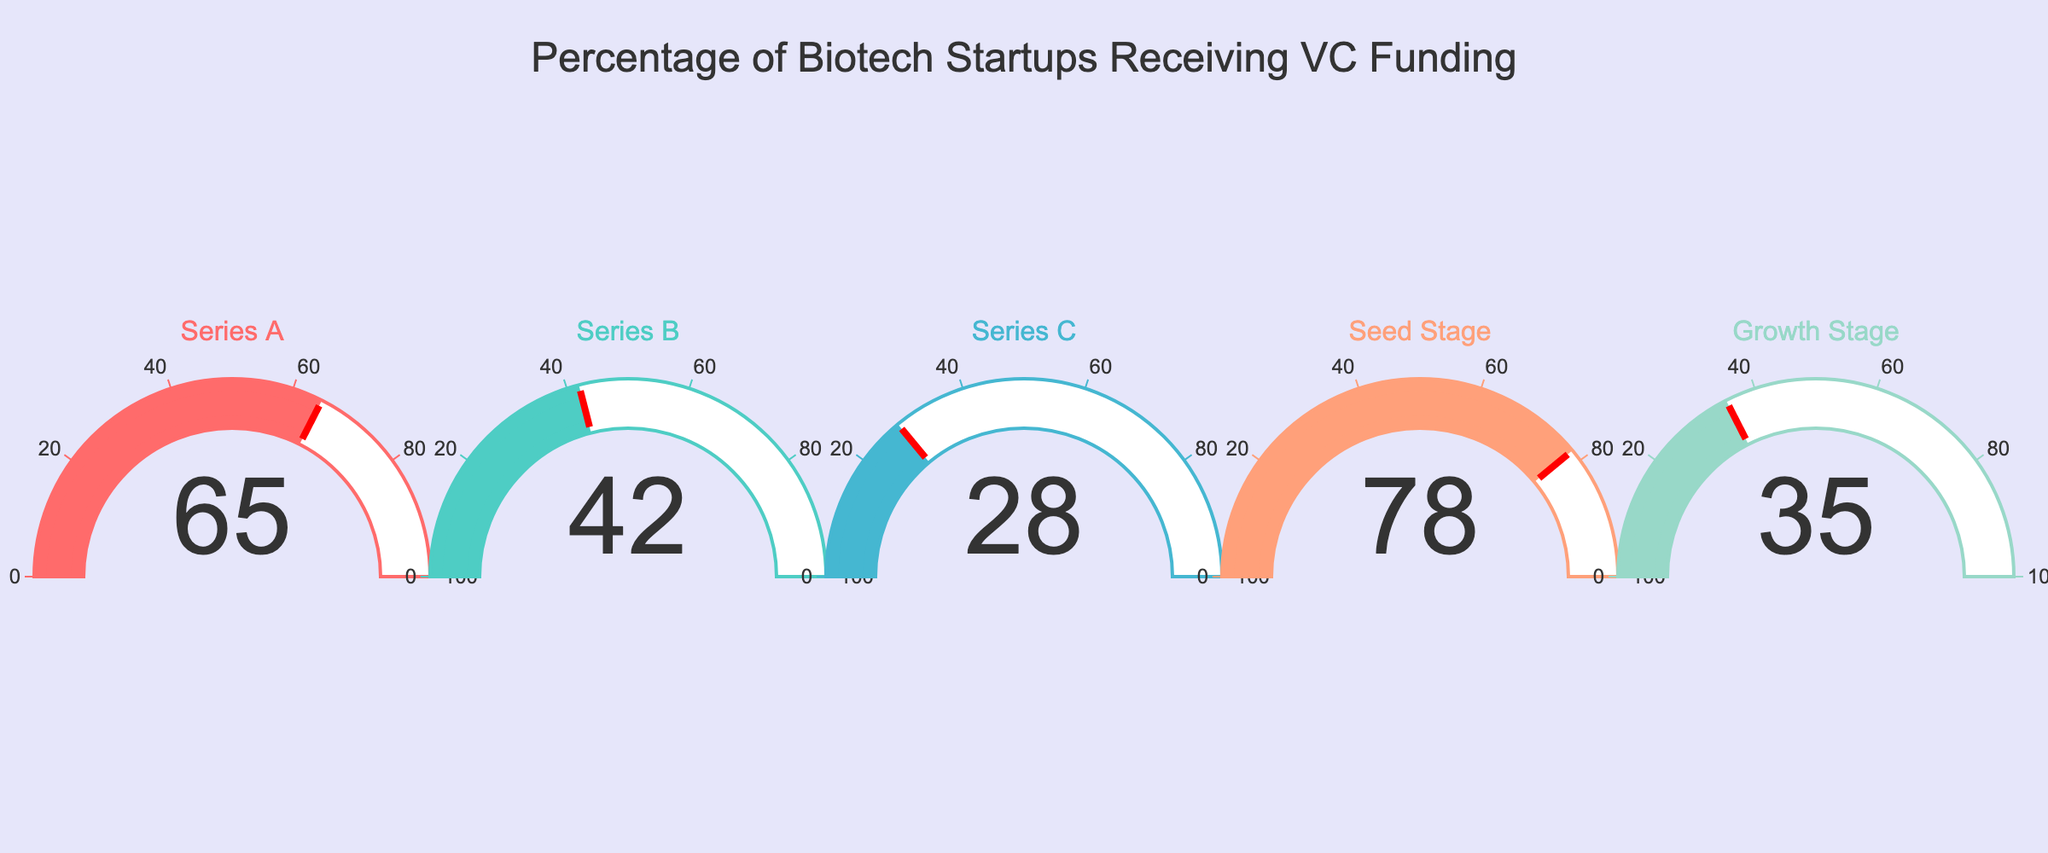What's the title of the figure? The title of the figure is usually displayed prominently at the top. In this figure, the title is located near the center at the top of the image.
Answer: Percentage of Biotech Startups Receiving VC Funding How many different funding stages are represented in this figure? By observing the number of gauges displayed in the figure, each corresponding to a different funding stage. You can count the gauges to determine this.
Answer: 5 What percentage of Seed Stage startups receive venture capital funding? Look at the gauge labeled "Seed Stage" and read the number displayed within this gauge.
Answer: 78% Which funding stage has the lowest percentage of startups receiving venture capital funding? By comparing all the percentages displayed on each gauge, identify the lowest number. The funding stage corresponding to this lowest number is the answer.
Answer: Series C How much higher is the percentage of Seed Stage funding compared to Series C funding? Determine the percentage for Seed Stage (78%) and Series C (28%) from their respective gauges. Subtract the Series C percentage from the Seed Stage percentage.
Answer: 50% Which two funding stages have the closest percentages? Compare the percentages for all pairs of funding stages and identify the pair with the smallest difference between their values.
Answer: Series B and Growth Stage What is the average percentage of biotech startups receiving venture capital funding across all stages? Add the percentages for all stages (65, 42, 28, 78, 35). Then divide the sum by the number of stages (5).
Answer: 49.6% In how many stages is the percentage of venture capital funding 50% or higher? Identify all gauges with a percentage value of 50 or higher by visually inspecting each gauge and counting those that meet the criterion.
Answer: 2 Which color is used to represent Series A funding? Look at the gauge labeled "Series A" and note the color of the gauge's bar and border.
Answer: Red Is the percentage of startups receiving Growth Stage funding greater than the percentage for Series B funding? Compare the percentages shown for Growth Stage (35%) and Series B (42%) by looking at their respective gauges.
Answer: No 